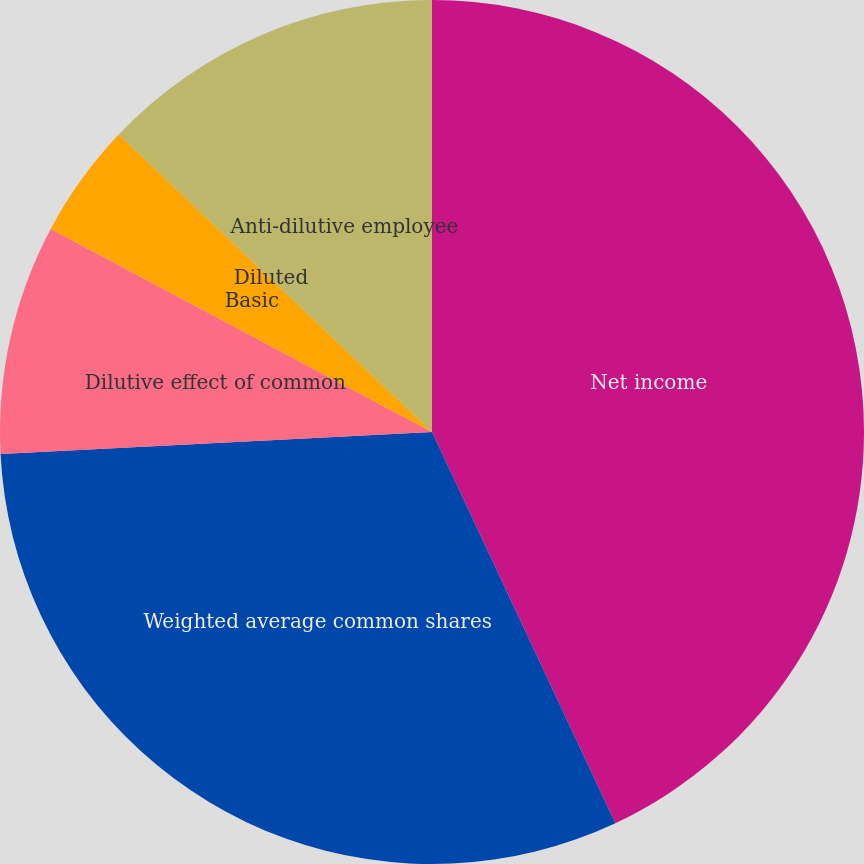Convert chart. <chart><loc_0><loc_0><loc_500><loc_500><pie_chart><fcel>Net income<fcel>Weighted average common shares<fcel>Dilutive effect of common<fcel>Basic<fcel>Diluted<fcel>Anti-dilutive employee<nl><fcel>43.02%<fcel>31.16%<fcel>8.6%<fcel>4.3%<fcel>0.0%<fcel>12.91%<nl></chart> 